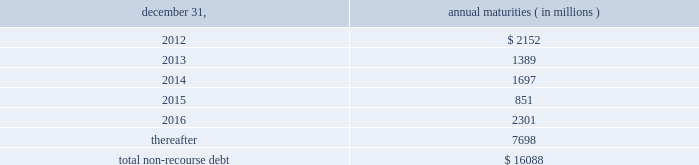The aes corporation notes to consolidated financial statements 2014 ( continued ) december 31 , 2011 , 2010 , and 2009 ( 1 ) weighted average interest rate at december 31 , 2011 .
( 2 ) the company has interest rate swaps and interest rate option agreements in an aggregate notional principal amount of approximately $ 3.6 billion on non-recourse debt outstanding at december 31 , 2011 .
The swap agreements economically change the variable interest rates on the portion of the debt covered by the notional amounts to fixed rates ranging from approximately 1.44% ( 1.44 % ) to 6.98% ( 6.98 % ) .
The option agreements fix interest rates within a range from 1.00% ( 1.00 % ) to 7.00% ( 7.00 % ) .
The agreements expire at various dates from 2016 through 2028 .
( 3 ) multilateral loans include loans funded and guaranteed by bilaterals , multilaterals , development banks and other similar institutions .
( 4 ) non-recourse debt of $ 704 million and $ 945 million as of december 31 , 2011 and 2010 , respectively , was excluded from non-recourse debt and included in current and long-term liabilities of held for sale and discontinued businesses in the accompanying consolidated balance sheets .
Non-recourse debt as of december 31 , 2011 is scheduled to reach maturity as set forth in the table below : december 31 , annual maturities ( in millions ) .
As of december 31 , 2011 , aes subsidiaries with facilities under construction had a total of approximately $ 1.4 billion of committed but unused credit facilities available to fund construction and other related costs .
Excluding these facilities under construction , aes subsidiaries had approximately $ 1.2 billion in a number of available but unused committed revolving credit lines to support their working capital , debt service reserves and other business needs .
These credit lines can be used in one or more of the following ways : solely for borrowings ; solely for letters of credit ; or a combination of these uses .
The weighted average interest rate on borrowings from these facilities was 14.75% ( 14.75 % ) at december 31 , 2011 .
On october 3 , 2011 , dolphin subsidiary ii , inc .
( 201cdolphin ii 201d ) , a newly formed , wholly-owned special purpose indirect subsidiary of aes , entered into an indenture ( the 201cindenture 201d ) with wells fargo bank , n.a .
( the 201ctrustee 201d ) as part of its issuance of $ 450 million aggregate principal amount of 6.50% ( 6.50 % ) senior notes due 2016 ( the 201c2016 notes 201d ) and $ 800 million aggregate principal amount of 7.25% ( 7.25 % ) senior notes due 2021 ( the 201c7.25% ( 201c7.25 % ) 2021 notes 201d , together with the 2016 notes , the 201cnotes 201d ) to finance the acquisition ( the 201cacquisition 201d ) of dpl .
Upon closing of the acquisition on november 28 , 2011 , dolphin ii was merged into dpl with dpl being the surviving entity and obligor .
The 2016 notes and the 7.25% ( 7.25 % ) 2021 notes are included under 201cnotes and bonds 201d in the non-recourse detail table above .
See note 23 2014acquisitions and dispositions for further information .
Interest on the 2016 notes and the 7.25% ( 7.25 % ) 2021 notes accrues at a rate of 6.50% ( 6.50 % ) and 7.25% ( 7.25 % ) per year , respectively , and is payable on april 15 and october 15 of each year , beginning april 15 , 2012 .
Prior to september 15 , 2016 with respect to the 2016 notes and july 15 , 2021 with respect to the 7.25% ( 7.25 % ) 2021 notes , dpl may redeem some or all of the 2016 notes or 7.25% ( 7.25 % ) 2021 notes at par , plus a 201cmake-whole 201d amount set forth in .
As of december 31 , 2011 , what is the total in billions available under the committed credit facilities? 
Computations: (1.4 + 1.2)
Answer: 2.6. The aes corporation notes to consolidated financial statements 2014 ( continued ) december 31 , 2011 , 2010 , and 2009 ( 1 ) weighted average interest rate at december 31 , 2011 .
( 2 ) the company has interest rate swaps and interest rate option agreements in an aggregate notional principal amount of approximately $ 3.6 billion on non-recourse debt outstanding at december 31 , 2011 .
The swap agreements economically change the variable interest rates on the portion of the debt covered by the notional amounts to fixed rates ranging from approximately 1.44% ( 1.44 % ) to 6.98% ( 6.98 % ) .
The option agreements fix interest rates within a range from 1.00% ( 1.00 % ) to 7.00% ( 7.00 % ) .
The agreements expire at various dates from 2016 through 2028 .
( 3 ) multilateral loans include loans funded and guaranteed by bilaterals , multilaterals , development banks and other similar institutions .
( 4 ) non-recourse debt of $ 704 million and $ 945 million as of december 31 , 2011 and 2010 , respectively , was excluded from non-recourse debt and included in current and long-term liabilities of held for sale and discontinued businesses in the accompanying consolidated balance sheets .
Non-recourse debt as of december 31 , 2011 is scheduled to reach maturity as set forth in the table below : december 31 , annual maturities ( in millions ) .
As of december 31 , 2011 , aes subsidiaries with facilities under construction had a total of approximately $ 1.4 billion of committed but unused credit facilities available to fund construction and other related costs .
Excluding these facilities under construction , aes subsidiaries had approximately $ 1.2 billion in a number of available but unused committed revolving credit lines to support their working capital , debt service reserves and other business needs .
These credit lines can be used in one or more of the following ways : solely for borrowings ; solely for letters of credit ; or a combination of these uses .
The weighted average interest rate on borrowings from these facilities was 14.75% ( 14.75 % ) at december 31 , 2011 .
On october 3 , 2011 , dolphin subsidiary ii , inc .
( 201cdolphin ii 201d ) , a newly formed , wholly-owned special purpose indirect subsidiary of aes , entered into an indenture ( the 201cindenture 201d ) with wells fargo bank , n.a .
( the 201ctrustee 201d ) as part of its issuance of $ 450 million aggregate principal amount of 6.50% ( 6.50 % ) senior notes due 2016 ( the 201c2016 notes 201d ) and $ 800 million aggregate principal amount of 7.25% ( 7.25 % ) senior notes due 2021 ( the 201c7.25% ( 201c7.25 % ) 2021 notes 201d , together with the 2016 notes , the 201cnotes 201d ) to finance the acquisition ( the 201cacquisition 201d ) of dpl .
Upon closing of the acquisition on november 28 , 2011 , dolphin ii was merged into dpl with dpl being the surviving entity and obligor .
The 2016 notes and the 7.25% ( 7.25 % ) 2021 notes are included under 201cnotes and bonds 201d in the non-recourse detail table above .
See note 23 2014acquisitions and dispositions for further information .
Interest on the 2016 notes and the 7.25% ( 7.25 % ) 2021 notes accrues at a rate of 6.50% ( 6.50 % ) and 7.25% ( 7.25 % ) per year , respectively , and is payable on april 15 and october 15 of each year , beginning april 15 , 2012 .
Prior to september 15 , 2016 with respect to the 2016 notes and july 15 , 2021 with respect to the 7.25% ( 7.25 % ) 2021 notes , dpl may redeem some or all of the 2016 notes or 7.25% ( 7.25 % ) 2021 notes at par , plus a 201cmake-whole 201d amount set forth in .
What percentage of total non-recourse debt as of december 31 , 2011 is due in 2014? 
Computations: (1697 / 16088)
Answer: 0.10548. 